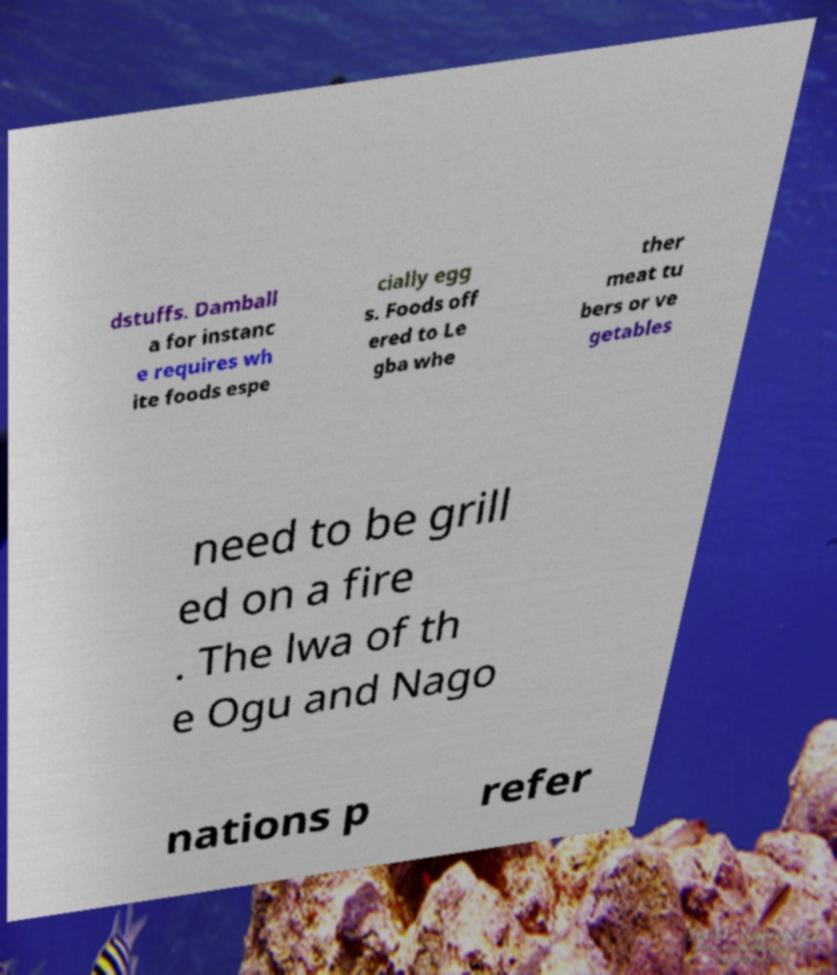Please identify and transcribe the text found in this image. dstuffs. Damball a for instanc e requires wh ite foods espe cially egg s. Foods off ered to Le gba whe ther meat tu bers or ve getables need to be grill ed on a fire . The lwa of th e Ogu and Nago nations p refer 